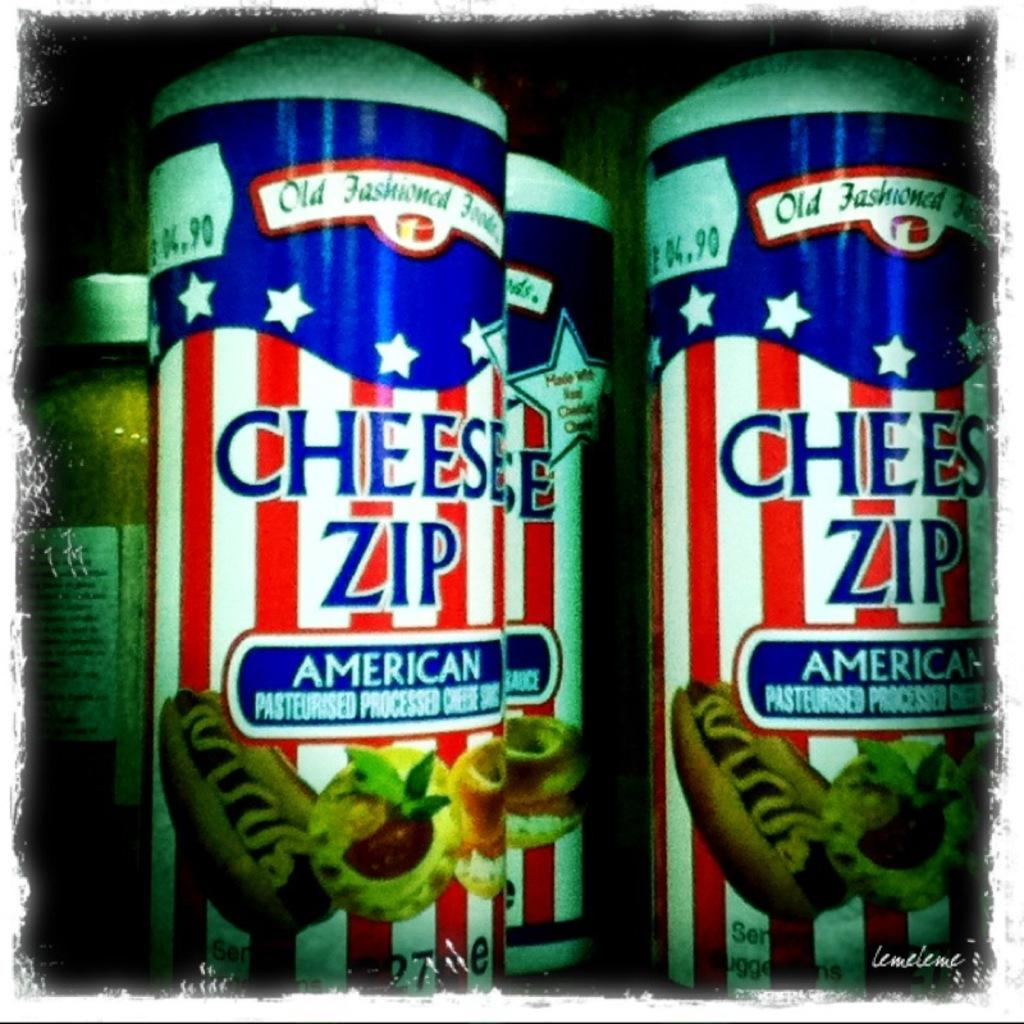What can be seen on the bottles in the image? There are bottles with stickers in the image. What do the stickers on the bottles depict? The stickers on the bottles have food items depicted. Is there any text on the stickers? Yes, there is text on the stickers. What else can be seen in the background of the image? There is a jar with a lid in the background of the image. What type of farmer is shown working in the image? There is no farmer present in the image; it only features bottles with stickers, text, and a jar with a lid in the background. 